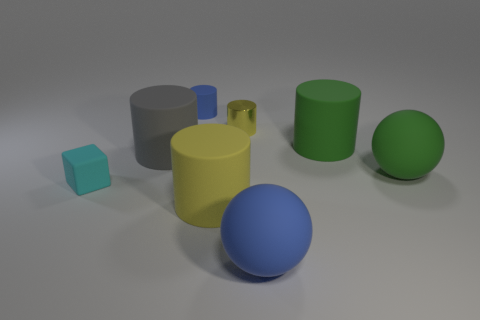The big object that is the same color as the tiny shiny thing is what shape?
Give a very brief answer. Cylinder. What is the size of the gray cylinder that is the same material as the small block?
Keep it short and to the point. Large. There is a rubber cylinder that is on the left side of the big yellow rubber object and in front of the tiny blue cylinder; what is its size?
Provide a short and direct response. Large. There is a yellow cylinder in front of the tiny rubber block; what number of big cylinders are to the right of it?
Ensure brevity in your answer.  1. Is the tiny yellow metallic thing the same shape as the large gray object?
Offer a very short reply. Yes. Are there any other things of the same color as the metal cylinder?
Offer a terse response. Yes. Do the big gray thing and the metallic thing in front of the blue cylinder have the same shape?
Your response must be concise. Yes. The rubber sphere behind the rubber ball left of the big ball that is on the right side of the large green matte cylinder is what color?
Give a very brief answer. Green. Is there any other thing that is the same material as the tiny yellow cylinder?
Provide a succinct answer. No. There is a large matte thing left of the large yellow cylinder; is its shape the same as the large blue thing?
Offer a very short reply. No. 